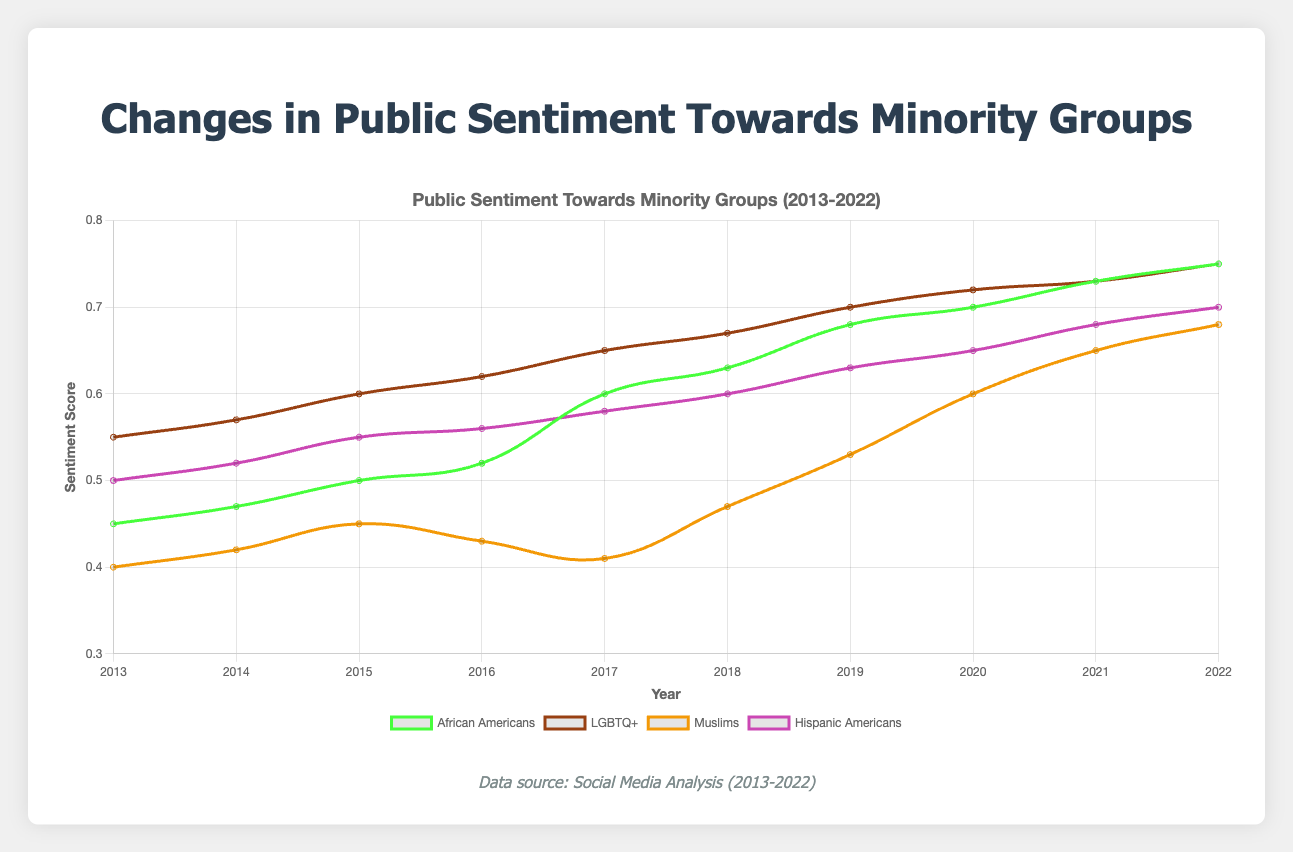What is the general trend in public sentiment towards African Americans from 2013 to 2022? The public sentiment towards African Americans has shown an upward trend from 2013 (0.45) to 2022 (0.75), indicating an improvement over the decade.
Answer: Upward Which year did the public sentiment towards Muslims show the largest improvement? The largest improvement in sentiment towards Muslims can be observed between 2017 (0.41) and 2018 (0.47), with an increase of 0.06 points.
Answer: 2018 Compare the sentiment scores for LGBTQ+ and Hispanic Americans in the year 2015. Which group had a higher sentiment score? In 2015, the sentiment score for LGBTQ+ was 0.60, while for Hispanic Americans it was 0.55. Therefore, LGBTQ+ had a higher sentiment score.
Answer: LGBTQ+ What is the average sentiment score for African Americans from 2013 to 2022? Sum of sentiment scores for African Americans from 2013 to 2022 is (0.45 + 0.47 + 0.50 + 0.52 + 0.60 + 0.63 + 0.68 + 0.70 + 0.73 + 0.75) = 6.03. There are 10 data points, so the average sentiment score is 6.03 / 10 = 0.603.
Answer: 0.603 Which group experienced the greatest overall improvement in sentiment score from 2013 to 2022? Sentiment score changes from 2013 to 2022: 
- African Americans: 0.75 - 0.45 = 0.30
- LGBTQ+: 0.75 - 0.55 = 0.20
- Muslims: 0.68 - 0.40 = 0.28
- Hispanic Americans: 0.70 - 0.50 = 0.20
The greatest overall improvement was observed in the African Americans group (0.30).
Answer: African Americans In which year did all groups have equal sentiment scores? In 2022, all groups had a sentiment score of 0.75.
Answer: 2022 How does the sentiment score for Muslims in 2016 compare to their score in 2014? In 2016, the sentiment score for Muslims was 0.43, while in 2014 it was 0.42. Therefore, there was a slight increase of 0.01 points from 2014 to 2016.
Answer: Higher in 2016 Which group had the lowest sentiment score in 2017? In 2017, the sentiment scores were as follows: 
- African Americans: 0.60
- LGBTQ+: 0.65
- Muslims: 0.41
- Hispanic Americans: 0.58
The group with the lowest sentiment score was Muslims (0.41).
Answer: Muslims Calculate the sentiment score difference between the highest and lowest groups in 2019. In 2019, the highest sentiment score was for LGBTQ+ (0.70) and the lowest was for Muslims (0.53). The difference is 0.70 - 0.53 = 0.17.
Answer: 0.17 